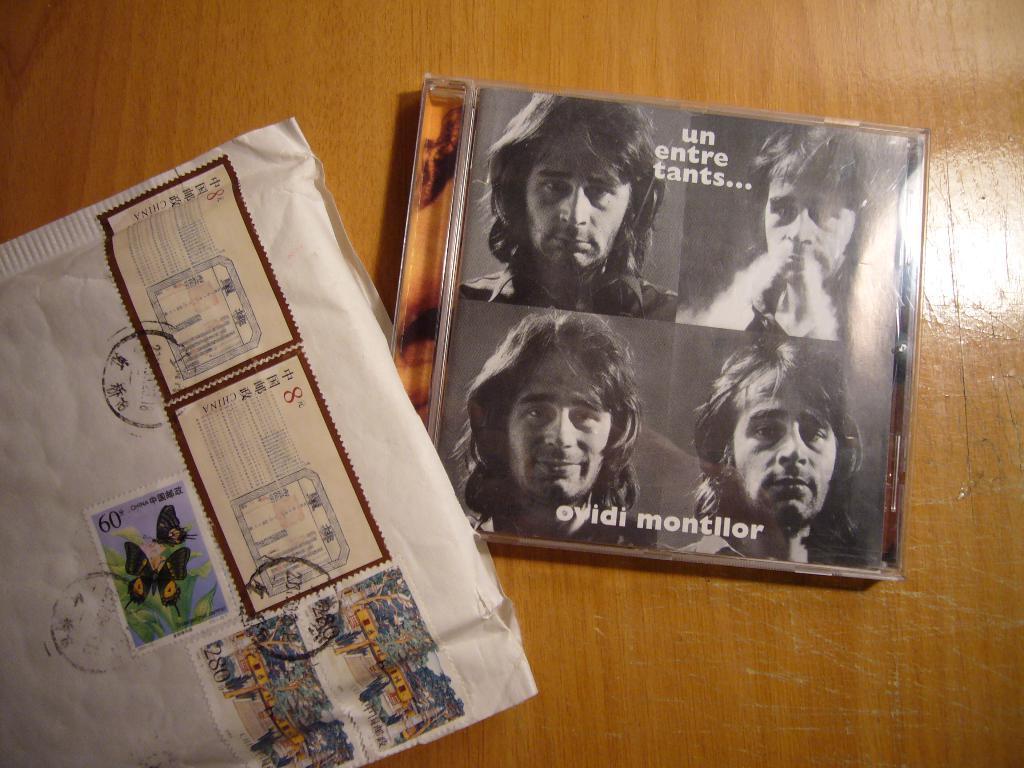Please provide a concise description of this image. On this wooden surface we can see a box, and an envelope with stamps. On this box we can see collage picture of a person. 